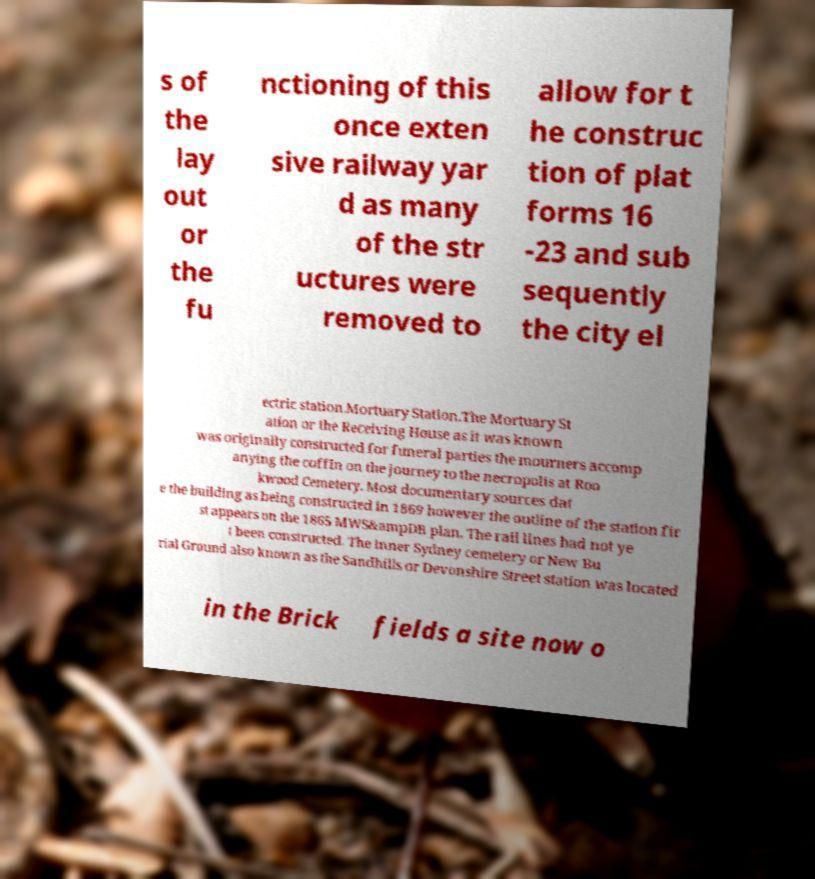Please identify and transcribe the text found in this image. s of the lay out or the fu nctioning of this once exten sive railway yar d as many of the str uctures were removed to allow for t he construc tion of plat forms 16 -23 and sub sequently the city el ectric station.Mortuary Station.The Mortuary St ation or the Receiving House as it was known was originally constructed for funeral parties the mourners accomp anying the coffin on the journey to the necropolis at Roo kwood Cemetery. Most documentary sources dat e the building as being constructed in 1869 however the outline of the station fir st appears on the 1865 MWS&ampDB plan. The rail lines had not ye t been constructed. The inner Sydney cemetery or New Bu rial Ground also known as the Sandhills or Devonshire Street station was located in the Brick fields a site now o 